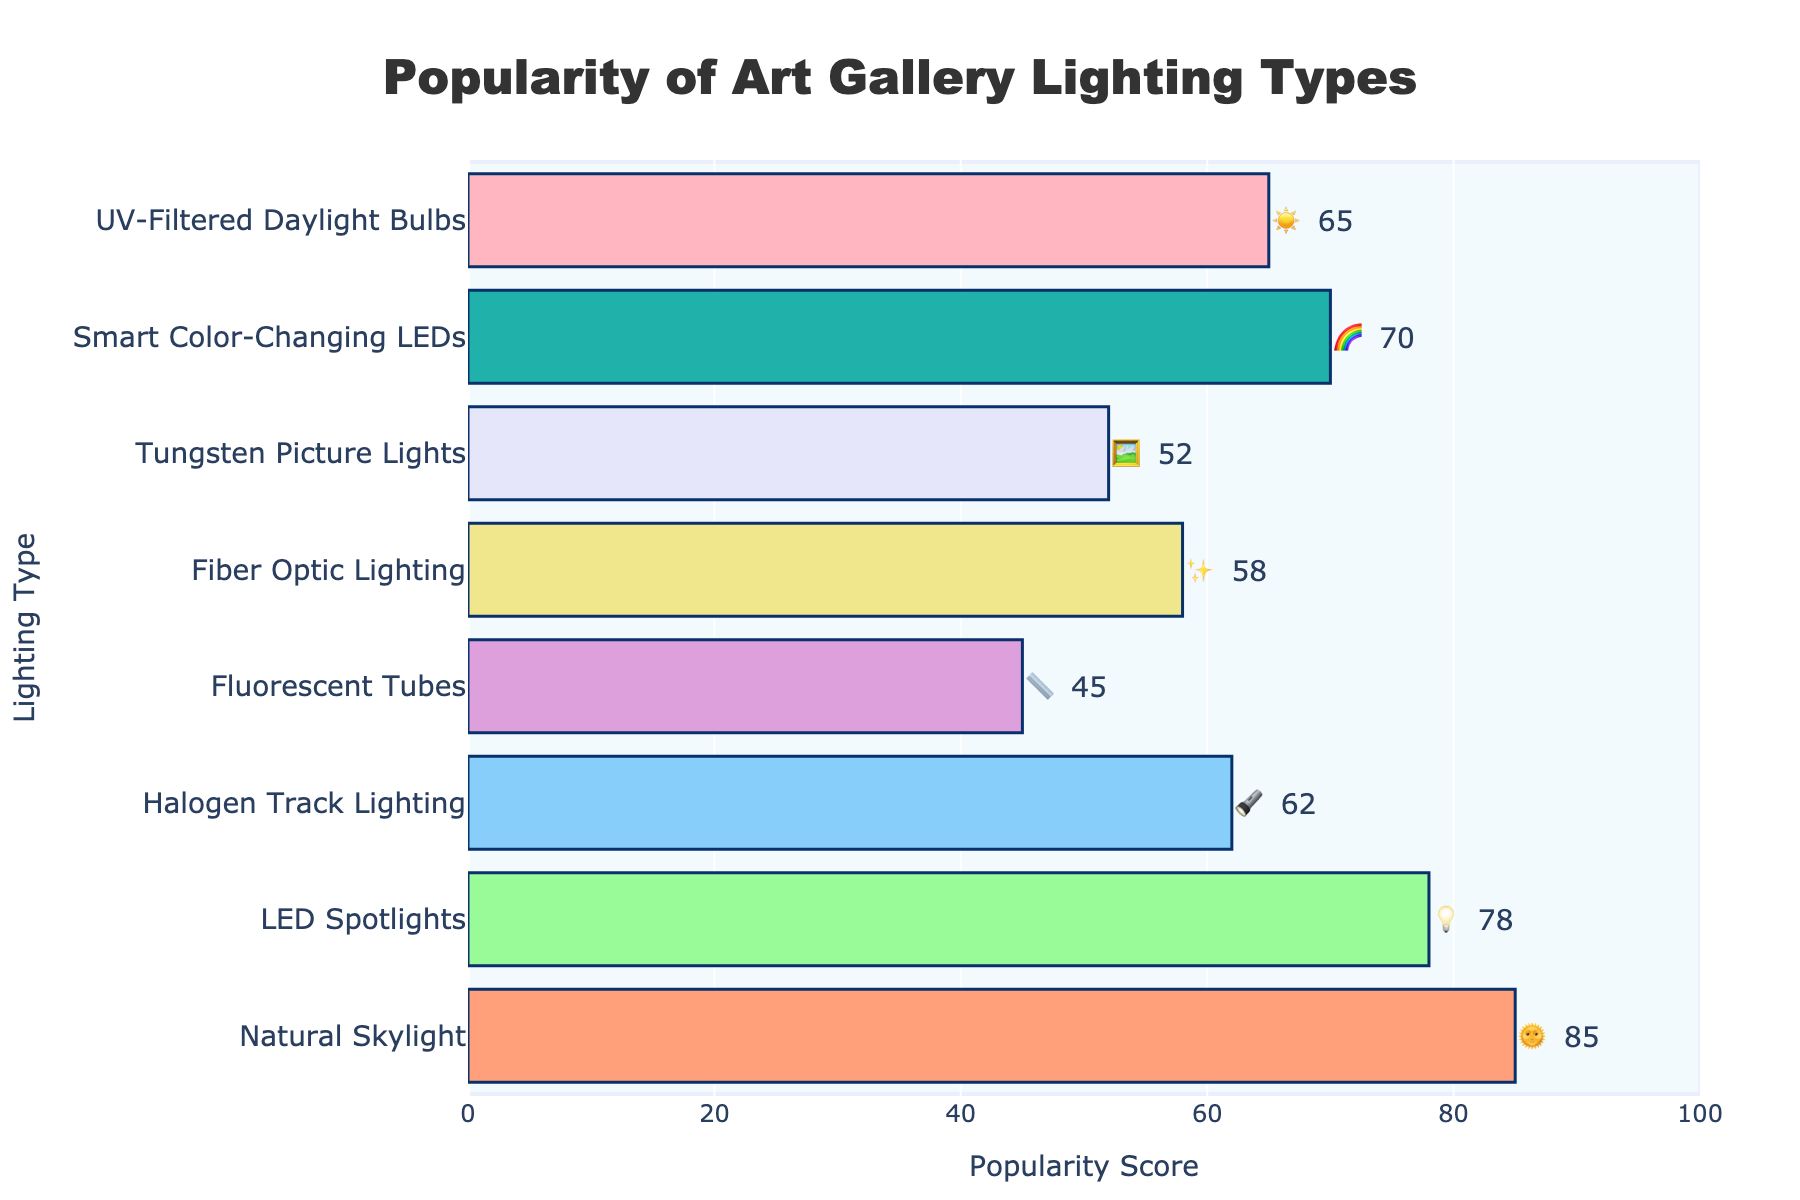What's the most popular lighting type in art galleries? The figure shows various lighting types with their popularity scores. By looking at the scores, "Natural Skylight" has an 85 which is the highest.
Answer: Natural Skylight Which lighting type has the lowest popularity score? Observing the bar lengths and scores, "Fluorescent Tubes" has the lowest score at 45.
Answer: Fluorescent Tubes What is the total popularity score of Smart Color-Changing LEDs and UV-Filtered Daylight Bulbs? Add the popularity scores of "Smart Color-Changing LEDs" (70) and "UV-Filtered Daylight Bulbs" (65).
Answer: 135 How much more popular are LED Spotlights than Halogen Track Lighting? Subtract the popularity score of "Halogen Track Lighting" (62) from that of "LED Spotlights" (78) to find the difference.
Answer: 16 Which two lighting types have the closest popularity scores? Comparing the scores, "Halogen Track Lighting" (62) and "Fiber Optic Lighting" (58) have the closest scores with a difference of 4.
Answer: Halogen Track Lighting and Fiber Optic Lighting On average, how popular are the lighting types with scores above 60? Sum the scores above 60: Natural Skylight (85), LED Spotlights (78), Halogen Track Lighting (62), Smart Color-Changing LEDs (70), UV-Filtered Daylight Bulbs (65). The sum is 360; divide by the number of types (5).
Answer: 72 Identify the colors associated with the two least popular lighting types. The two least popular lighting types are "Fluorescent Tubes" and "Tungsten Picture Lights" with scores of 45 and 52, respectively. Their colors are indicated on the chart.
Answer: Light yellow and Light purple Is Fiber Optic Lighting more popular than Tungsten Picture Lights and by how much? Compare their popularity scores: Fiber Optic Lighting (58) and Tungsten Picture Lights (52). Subtract the latter from the former.
Answer: 6 What is the average popularity score of all lighting types? Add all popularity scores: 85 + 78 + 62 + 45 + 58 + 52 + 70 + 65 = 515. Divide by the number of types (8).
Answer: 64.375 